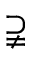<formula> <loc_0><loc_0><loc_500><loc_500>\supsetneqq</formula> 